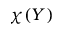Convert formula to latex. <formula><loc_0><loc_0><loc_500><loc_500>\chi ( Y )</formula> 